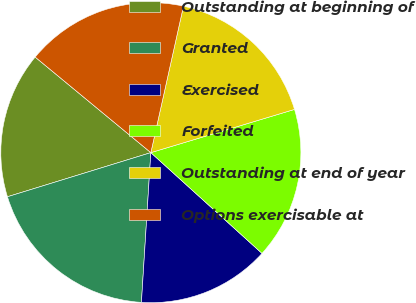Convert chart to OTSL. <chart><loc_0><loc_0><loc_500><loc_500><pie_chart><fcel>Outstanding at beginning of<fcel>Granted<fcel>Exercised<fcel>Forfeited<fcel>Outstanding at end of year<fcel>Options exercisable at<nl><fcel>15.74%<fcel>19.25%<fcel>14.28%<fcel>16.37%<fcel>16.86%<fcel>17.5%<nl></chart> 